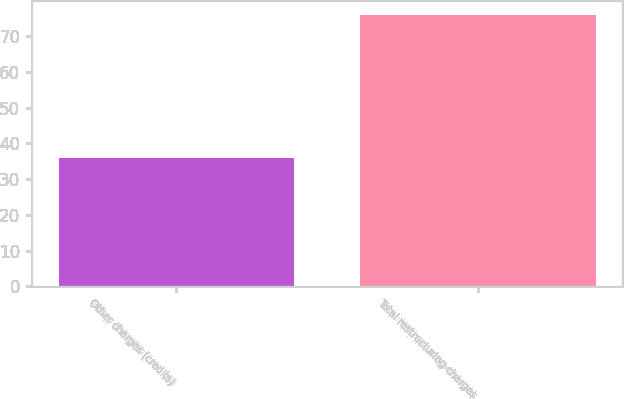Convert chart to OTSL. <chart><loc_0><loc_0><loc_500><loc_500><bar_chart><fcel>Other charges (credits)<fcel>Total restructuring charges<nl><fcel>36<fcel>76<nl></chart> 